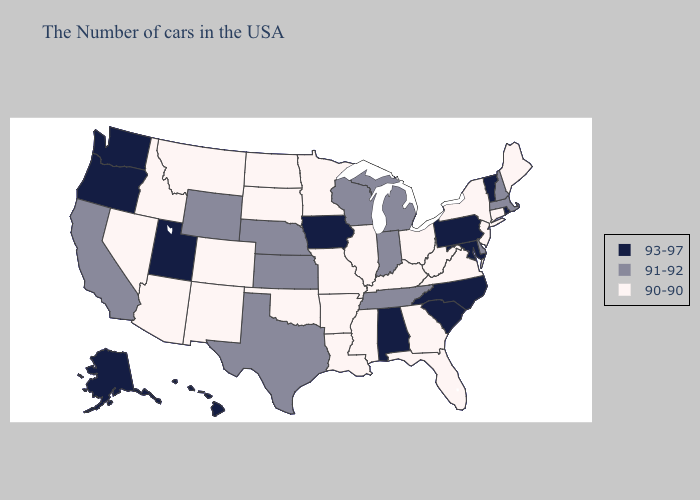Does the map have missing data?
Answer briefly. No. Does Kansas have the same value as Maryland?
Quick response, please. No. What is the highest value in states that border Arkansas?
Be succinct. 91-92. Does Mississippi have the highest value in the USA?
Keep it brief. No. Which states have the highest value in the USA?
Short answer required. Rhode Island, Vermont, Maryland, Pennsylvania, North Carolina, South Carolina, Alabama, Iowa, Utah, Washington, Oregon, Alaska, Hawaii. What is the lowest value in the West?
Quick response, please. 90-90. Does the first symbol in the legend represent the smallest category?
Quick response, please. No. Name the states that have a value in the range 93-97?
Concise answer only. Rhode Island, Vermont, Maryland, Pennsylvania, North Carolina, South Carolina, Alabama, Iowa, Utah, Washington, Oregon, Alaska, Hawaii. What is the value of Connecticut?
Be succinct. 90-90. Which states have the lowest value in the West?
Give a very brief answer. Colorado, New Mexico, Montana, Arizona, Idaho, Nevada. What is the value of Oklahoma?
Be succinct. 90-90. Among the states that border South Dakota , does Montana have the lowest value?
Short answer required. Yes. Which states have the lowest value in the USA?
Keep it brief. Maine, Connecticut, New York, New Jersey, Virginia, West Virginia, Ohio, Florida, Georgia, Kentucky, Illinois, Mississippi, Louisiana, Missouri, Arkansas, Minnesota, Oklahoma, South Dakota, North Dakota, Colorado, New Mexico, Montana, Arizona, Idaho, Nevada. What is the highest value in the MidWest ?
Write a very short answer. 93-97. What is the highest value in the USA?
Quick response, please. 93-97. 